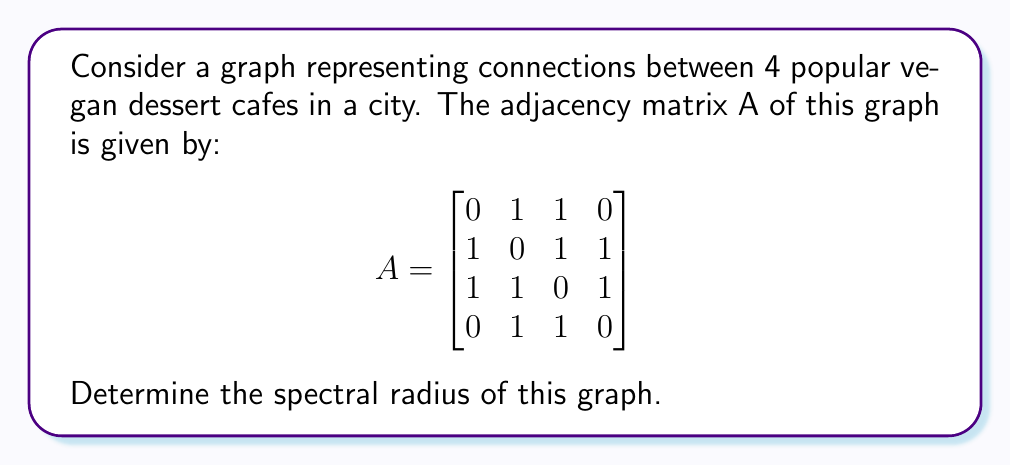Provide a solution to this math problem. To find the spectral radius of the graph, we need to follow these steps:

1) The spectral radius is the largest absolute value of the eigenvalues of the adjacency matrix A.

2) To find the eigenvalues, we need to solve the characteristic equation:
   $\det(A - \lambda I) = 0$

3) Expanding this, we get:
   $$\begin{vmatrix}
   -\lambda & 1 & 1 & 0 \\
   1 & -\lambda & 1 & 1 \\
   1 & 1 & -\lambda & 1 \\
   0 & 1 & 1 & -\lambda
   \end{vmatrix} = 0$$

4) Calculating this determinant:
   $\lambda^4 - 5\lambda^2 - 4\lambda + 1 = 0$

5) This is a 4th degree polynomial. It's not easy to solve by hand, but we can use numerical methods or computer algebra systems to find the roots.

6) The roots (eigenvalues) are approximately:
   $\lambda_1 \approx 2.4812$
   $\lambda_2 \approx -1.7019$
   $\lambda_3 \approx 0.5104$
   $\lambda_4 \approx -0.2897$

7) The spectral radius is the largest absolute value among these eigenvalues, which is $|\lambda_1| \approx 2.4812$.
Answer: $2.4812$ 